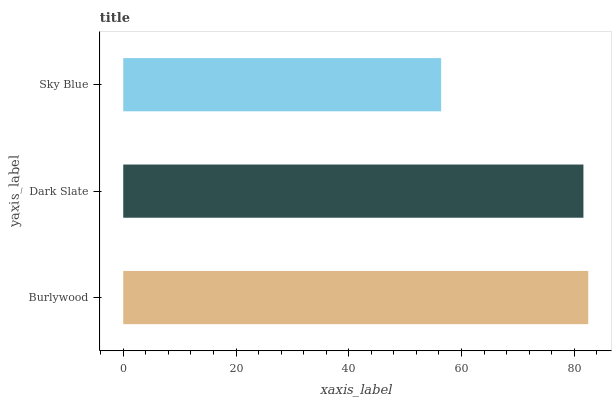Is Sky Blue the minimum?
Answer yes or no. Yes. Is Burlywood the maximum?
Answer yes or no. Yes. Is Dark Slate the minimum?
Answer yes or no. No. Is Dark Slate the maximum?
Answer yes or no. No. Is Burlywood greater than Dark Slate?
Answer yes or no. Yes. Is Dark Slate less than Burlywood?
Answer yes or no. Yes. Is Dark Slate greater than Burlywood?
Answer yes or no. No. Is Burlywood less than Dark Slate?
Answer yes or no. No. Is Dark Slate the high median?
Answer yes or no. Yes. Is Dark Slate the low median?
Answer yes or no. Yes. Is Sky Blue the high median?
Answer yes or no. No. Is Sky Blue the low median?
Answer yes or no. No. 